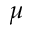Convert formula to latex. <formula><loc_0><loc_0><loc_500><loc_500>\mu</formula> 